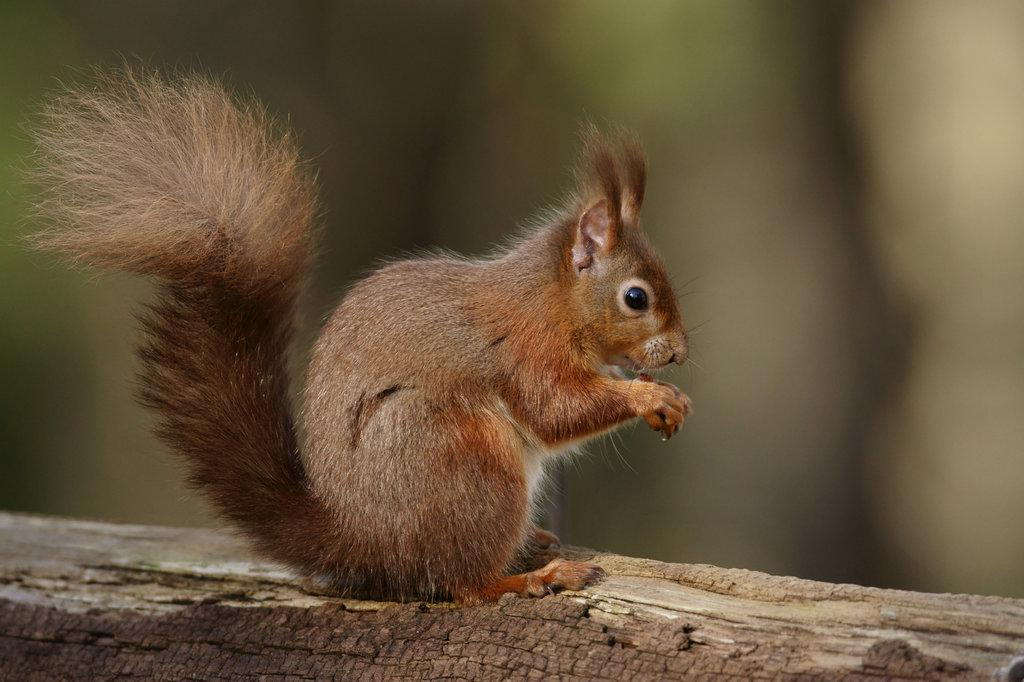What type of animal is in the image? There is a squirrel in the image. What surface is the squirrel on? The squirrel is on a wooden surface. Can you describe the background of the image? The background of the image is blurred. What type of desk is visible in the image? There is no desk present in the image; it features a squirrel on a wooden surface. How many fingers can be seen touching the squirrel in the image? There are no fingers touching the squirrel in the image. 